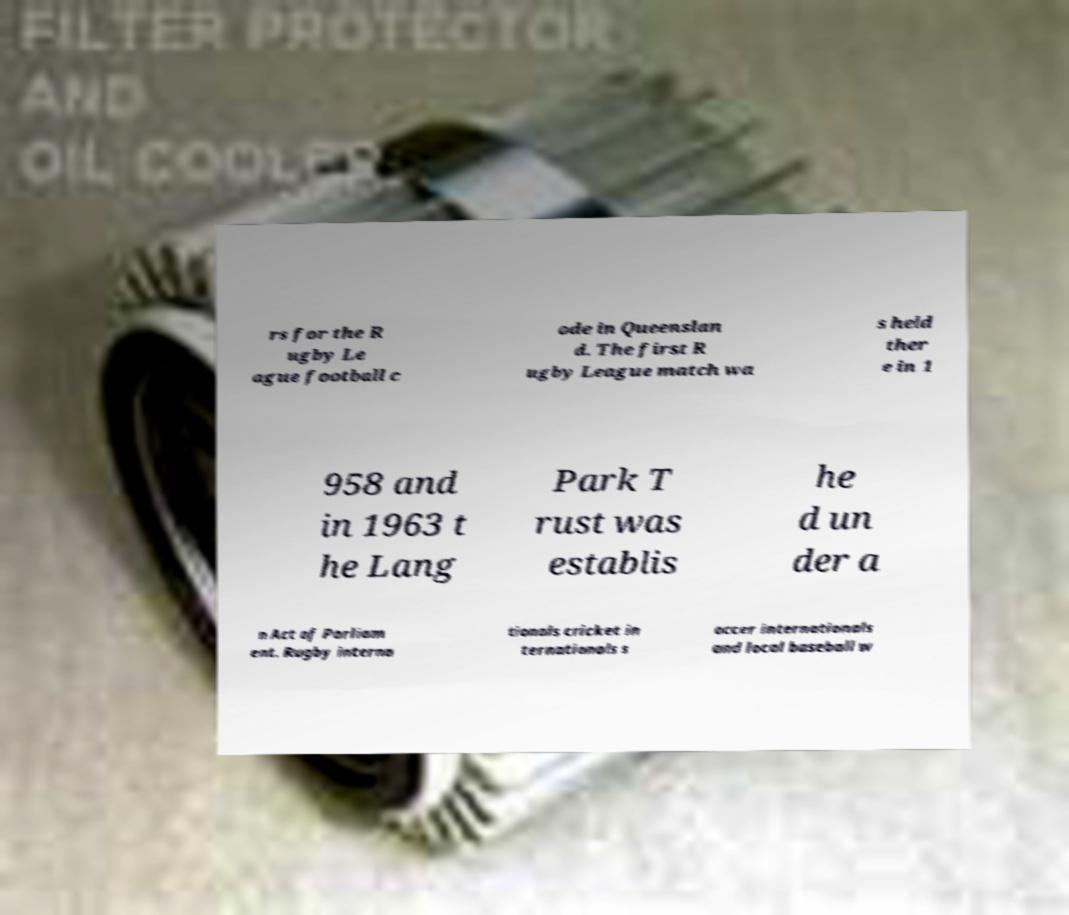What messages or text are displayed in this image? I need them in a readable, typed format. rs for the R ugby Le ague football c ode in Queenslan d. The first R ugby League match wa s held ther e in 1 958 and in 1963 t he Lang Park T rust was establis he d un der a n Act of Parliam ent. Rugby interna tionals cricket in ternationals s occer internationals and local baseball w 